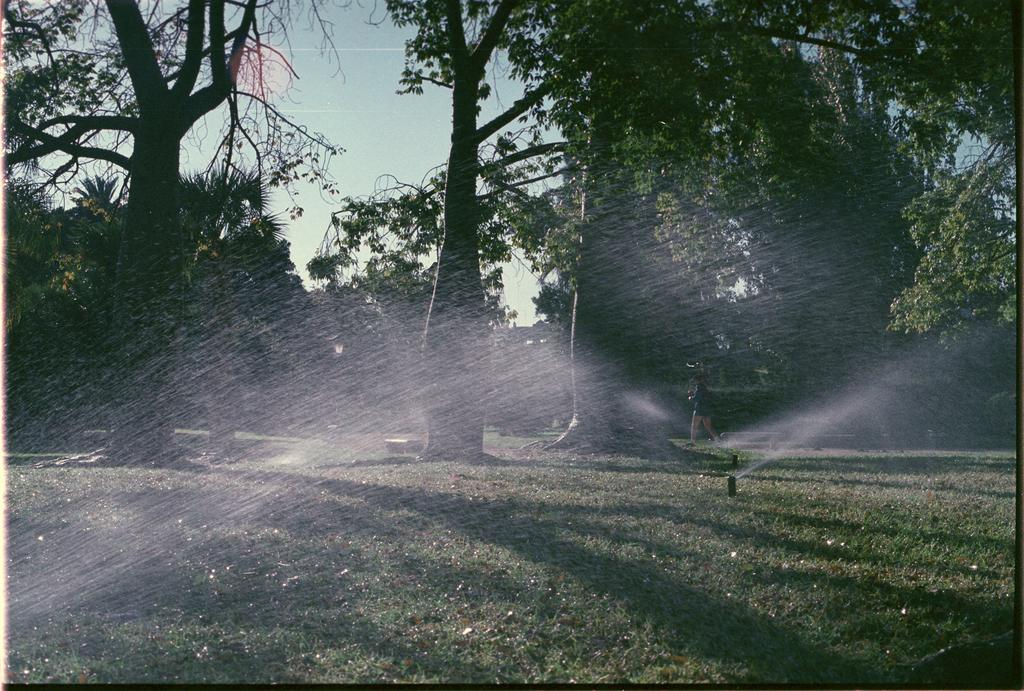What type of vegetation can be seen in the image? There is grass in the image. What is used to water the grass in the image? There are sprinklers in the image. What is the source of water in the image? Water is visible in the image. What is the person in the image doing? There is a person walking in the image. What other natural elements can be seen in the image? There are trees in the image. What is visible in the background of the image? The sky is visible in the background of the image. What color is the gold notebook being held by the person in the image? There is no person holding a gold notebook in the image; the person is walking and there is no mention of a notebook. How does the person's breath affect the water in the image? The person's breath does not affect the water in the image; there is no interaction between the person and the water. 